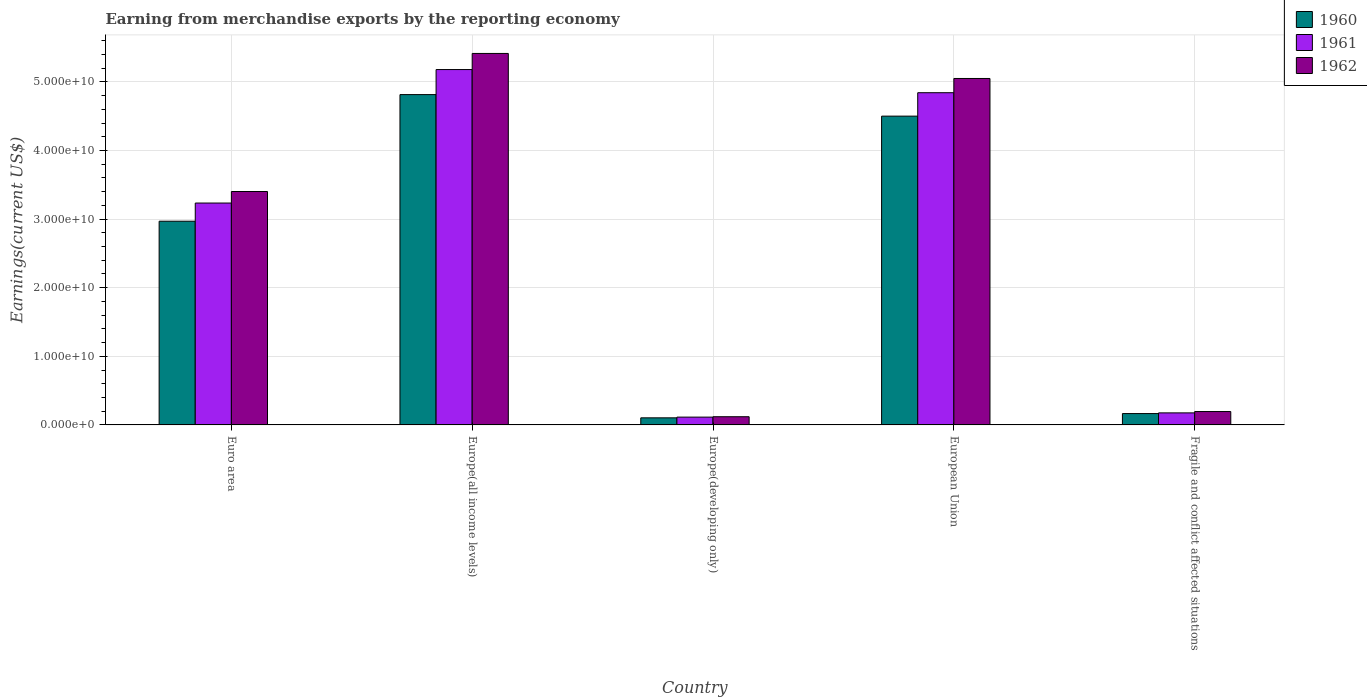Are the number of bars per tick equal to the number of legend labels?
Provide a short and direct response. Yes. How many bars are there on the 4th tick from the right?
Provide a succinct answer. 3. What is the amount earned from merchandise exports in 1960 in Europe(developing only)?
Your response must be concise. 1.03e+09. Across all countries, what is the maximum amount earned from merchandise exports in 1961?
Keep it short and to the point. 5.18e+1. Across all countries, what is the minimum amount earned from merchandise exports in 1962?
Keep it short and to the point. 1.19e+09. In which country was the amount earned from merchandise exports in 1960 maximum?
Offer a very short reply. Europe(all income levels). In which country was the amount earned from merchandise exports in 1960 minimum?
Keep it short and to the point. Europe(developing only). What is the total amount earned from merchandise exports in 1961 in the graph?
Ensure brevity in your answer.  1.35e+11. What is the difference between the amount earned from merchandise exports in 1962 in European Union and that in Fragile and conflict affected situations?
Ensure brevity in your answer.  4.86e+1. What is the difference between the amount earned from merchandise exports in 1961 in Europe(developing only) and the amount earned from merchandise exports in 1962 in Euro area?
Keep it short and to the point. -3.29e+1. What is the average amount earned from merchandise exports in 1962 per country?
Keep it short and to the point. 2.84e+1. What is the difference between the amount earned from merchandise exports of/in 1962 and amount earned from merchandise exports of/in 1961 in Fragile and conflict affected situations?
Offer a very short reply. 1.95e+08. In how many countries, is the amount earned from merchandise exports in 1960 greater than 20000000000 US$?
Provide a short and direct response. 3. What is the ratio of the amount earned from merchandise exports in 1962 in Euro area to that in Europe(all income levels)?
Your answer should be compact. 0.63. What is the difference between the highest and the second highest amount earned from merchandise exports in 1962?
Your response must be concise. 3.65e+09. What is the difference between the highest and the lowest amount earned from merchandise exports in 1961?
Keep it short and to the point. 5.07e+1. In how many countries, is the amount earned from merchandise exports in 1962 greater than the average amount earned from merchandise exports in 1962 taken over all countries?
Keep it short and to the point. 3. Is the sum of the amount earned from merchandise exports in 1961 in Europe(all income levels) and Fragile and conflict affected situations greater than the maximum amount earned from merchandise exports in 1960 across all countries?
Make the answer very short. Yes. Are all the bars in the graph horizontal?
Make the answer very short. No. Does the graph contain any zero values?
Your answer should be compact. No. Does the graph contain grids?
Your answer should be very brief. Yes. Where does the legend appear in the graph?
Provide a succinct answer. Top right. How many legend labels are there?
Provide a succinct answer. 3. How are the legend labels stacked?
Provide a short and direct response. Vertical. What is the title of the graph?
Your response must be concise. Earning from merchandise exports by the reporting economy. Does "2015" appear as one of the legend labels in the graph?
Give a very brief answer. No. What is the label or title of the Y-axis?
Make the answer very short. Earnings(current US$). What is the Earnings(current US$) in 1960 in Euro area?
Keep it short and to the point. 2.97e+1. What is the Earnings(current US$) in 1961 in Euro area?
Offer a terse response. 3.23e+1. What is the Earnings(current US$) in 1962 in Euro area?
Your response must be concise. 3.40e+1. What is the Earnings(current US$) in 1960 in Europe(all income levels)?
Offer a very short reply. 4.82e+1. What is the Earnings(current US$) of 1961 in Europe(all income levels)?
Give a very brief answer. 5.18e+1. What is the Earnings(current US$) of 1962 in Europe(all income levels)?
Make the answer very short. 5.42e+1. What is the Earnings(current US$) in 1960 in Europe(developing only)?
Make the answer very short. 1.03e+09. What is the Earnings(current US$) in 1961 in Europe(developing only)?
Make the answer very short. 1.14e+09. What is the Earnings(current US$) of 1962 in Europe(developing only)?
Ensure brevity in your answer.  1.19e+09. What is the Earnings(current US$) of 1960 in European Union?
Provide a succinct answer. 4.50e+1. What is the Earnings(current US$) in 1961 in European Union?
Give a very brief answer. 4.84e+1. What is the Earnings(current US$) in 1962 in European Union?
Your response must be concise. 5.05e+1. What is the Earnings(current US$) in 1960 in Fragile and conflict affected situations?
Offer a very short reply. 1.65e+09. What is the Earnings(current US$) of 1961 in Fragile and conflict affected situations?
Offer a very short reply. 1.75e+09. What is the Earnings(current US$) of 1962 in Fragile and conflict affected situations?
Ensure brevity in your answer.  1.95e+09. Across all countries, what is the maximum Earnings(current US$) in 1960?
Give a very brief answer. 4.82e+1. Across all countries, what is the maximum Earnings(current US$) in 1961?
Make the answer very short. 5.18e+1. Across all countries, what is the maximum Earnings(current US$) of 1962?
Your answer should be compact. 5.42e+1. Across all countries, what is the minimum Earnings(current US$) of 1960?
Provide a succinct answer. 1.03e+09. Across all countries, what is the minimum Earnings(current US$) of 1961?
Your answer should be compact. 1.14e+09. Across all countries, what is the minimum Earnings(current US$) in 1962?
Provide a short and direct response. 1.19e+09. What is the total Earnings(current US$) of 1960 in the graph?
Your response must be concise. 1.26e+11. What is the total Earnings(current US$) in 1961 in the graph?
Your response must be concise. 1.35e+11. What is the total Earnings(current US$) of 1962 in the graph?
Give a very brief answer. 1.42e+11. What is the difference between the Earnings(current US$) in 1960 in Euro area and that in Europe(all income levels)?
Ensure brevity in your answer.  -1.85e+1. What is the difference between the Earnings(current US$) of 1961 in Euro area and that in Europe(all income levels)?
Provide a short and direct response. -1.95e+1. What is the difference between the Earnings(current US$) of 1962 in Euro area and that in Europe(all income levels)?
Keep it short and to the point. -2.01e+1. What is the difference between the Earnings(current US$) in 1960 in Euro area and that in Europe(developing only)?
Give a very brief answer. 2.87e+1. What is the difference between the Earnings(current US$) in 1961 in Euro area and that in Europe(developing only)?
Keep it short and to the point. 3.12e+1. What is the difference between the Earnings(current US$) in 1962 in Euro area and that in Europe(developing only)?
Offer a very short reply. 3.28e+1. What is the difference between the Earnings(current US$) of 1960 in Euro area and that in European Union?
Offer a very short reply. -1.53e+1. What is the difference between the Earnings(current US$) of 1961 in Euro area and that in European Union?
Keep it short and to the point. -1.61e+1. What is the difference between the Earnings(current US$) of 1962 in Euro area and that in European Union?
Give a very brief answer. -1.65e+1. What is the difference between the Earnings(current US$) of 1960 in Euro area and that in Fragile and conflict affected situations?
Ensure brevity in your answer.  2.80e+1. What is the difference between the Earnings(current US$) of 1961 in Euro area and that in Fragile and conflict affected situations?
Provide a short and direct response. 3.06e+1. What is the difference between the Earnings(current US$) in 1962 in Euro area and that in Fragile and conflict affected situations?
Make the answer very short. 3.21e+1. What is the difference between the Earnings(current US$) of 1960 in Europe(all income levels) and that in Europe(developing only)?
Make the answer very short. 4.71e+1. What is the difference between the Earnings(current US$) of 1961 in Europe(all income levels) and that in Europe(developing only)?
Offer a terse response. 5.07e+1. What is the difference between the Earnings(current US$) of 1962 in Europe(all income levels) and that in Europe(developing only)?
Offer a very short reply. 5.30e+1. What is the difference between the Earnings(current US$) of 1960 in Europe(all income levels) and that in European Union?
Give a very brief answer. 3.14e+09. What is the difference between the Earnings(current US$) of 1961 in Europe(all income levels) and that in European Union?
Provide a short and direct response. 3.38e+09. What is the difference between the Earnings(current US$) of 1962 in Europe(all income levels) and that in European Union?
Keep it short and to the point. 3.65e+09. What is the difference between the Earnings(current US$) of 1960 in Europe(all income levels) and that in Fragile and conflict affected situations?
Your answer should be very brief. 4.65e+1. What is the difference between the Earnings(current US$) in 1961 in Europe(all income levels) and that in Fragile and conflict affected situations?
Provide a short and direct response. 5.00e+1. What is the difference between the Earnings(current US$) in 1962 in Europe(all income levels) and that in Fragile and conflict affected situations?
Your answer should be compact. 5.22e+1. What is the difference between the Earnings(current US$) in 1960 in Europe(developing only) and that in European Union?
Offer a very short reply. -4.40e+1. What is the difference between the Earnings(current US$) of 1961 in Europe(developing only) and that in European Union?
Offer a very short reply. -4.73e+1. What is the difference between the Earnings(current US$) in 1962 in Europe(developing only) and that in European Union?
Offer a very short reply. -4.93e+1. What is the difference between the Earnings(current US$) in 1960 in Europe(developing only) and that in Fragile and conflict affected situations?
Offer a terse response. -6.22e+08. What is the difference between the Earnings(current US$) of 1961 in Europe(developing only) and that in Fragile and conflict affected situations?
Provide a succinct answer. -6.19e+08. What is the difference between the Earnings(current US$) in 1962 in Europe(developing only) and that in Fragile and conflict affected situations?
Give a very brief answer. -7.55e+08. What is the difference between the Earnings(current US$) in 1960 in European Union and that in Fragile and conflict affected situations?
Make the answer very short. 4.34e+1. What is the difference between the Earnings(current US$) in 1961 in European Union and that in Fragile and conflict affected situations?
Offer a very short reply. 4.67e+1. What is the difference between the Earnings(current US$) in 1962 in European Union and that in Fragile and conflict affected situations?
Ensure brevity in your answer.  4.86e+1. What is the difference between the Earnings(current US$) of 1960 in Euro area and the Earnings(current US$) of 1961 in Europe(all income levels)?
Provide a succinct answer. -2.21e+1. What is the difference between the Earnings(current US$) of 1960 in Euro area and the Earnings(current US$) of 1962 in Europe(all income levels)?
Give a very brief answer. -2.45e+1. What is the difference between the Earnings(current US$) of 1961 in Euro area and the Earnings(current US$) of 1962 in Europe(all income levels)?
Offer a very short reply. -2.18e+1. What is the difference between the Earnings(current US$) in 1960 in Euro area and the Earnings(current US$) in 1961 in Europe(developing only)?
Your answer should be compact. 2.86e+1. What is the difference between the Earnings(current US$) of 1960 in Euro area and the Earnings(current US$) of 1962 in Europe(developing only)?
Ensure brevity in your answer.  2.85e+1. What is the difference between the Earnings(current US$) in 1961 in Euro area and the Earnings(current US$) in 1962 in Europe(developing only)?
Make the answer very short. 3.12e+1. What is the difference between the Earnings(current US$) in 1960 in Euro area and the Earnings(current US$) in 1961 in European Union?
Keep it short and to the point. -1.87e+1. What is the difference between the Earnings(current US$) in 1960 in Euro area and the Earnings(current US$) in 1962 in European Union?
Provide a short and direct response. -2.08e+1. What is the difference between the Earnings(current US$) of 1961 in Euro area and the Earnings(current US$) of 1962 in European Union?
Provide a succinct answer. -1.82e+1. What is the difference between the Earnings(current US$) of 1960 in Euro area and the Earnings(current US$) of 1961 in Fragile and conflict affected situations?
Offer a terse response. 2.79e+1. What is the difference between the Earnings(current US$) in 1960 in Euro area and the Earnings(current US$) in 1962 in Fragile and conflict affected situations?
Offer a very short reply. 2.77e+1. What is the difference between the Earnings(current US$) of 1961 in Euro area and the Earnings(current US$) of 1962 in Fragile and conflict affected situations?
Make the answer very short. 3.04e+1. What is the difference between the Earnings(current US$) in 1960 in Europe(all income levels) and the Earnings(current US$) in 1961 in Europe(developing only)?
Provide a succinct answer. 4.70e+1. What is the difference between the Earnings(current US$) in 1960 in Europe(all income levels) and the Earnings(current US$) in 1962 in Europe(developing only)?
Your answer should be very brief. 4.70e+1. What is the difference between the Earnings(current US$) in 1961 in Europe(all income levels) and the Earnings(current US$) in 1962 in Europe(developing only)?
Your answer should be very brief. 5.06e+1. What is the difference between the Earnings(current US$) in 1960 in Europe(all income levels) and the Earnings(current US$) in 1961 in European Union?
Your response must be concise. -2.75e+08. What is the difference between the Earnings(current US$) of 1960 in Europe(all income levels) and the Earnings(current US$) of 1962 in European Union?
Your response must be concise. -2.35e+09. What is the difference between the Earnings(current US$) of 1961 in Europe(all income levels) and the Earnings(current US$) of 1962 in European Union?
Ensure brevity in your answer.  1.30e+09. What is the difference between the Earnings(current US$) of 1960 in Europe(all income levels) and the Earnings(current US$) of 1961 in Fragile and conflict affected situations?
Keep it short and to the point. 4.64e+1. What is the difference between the Earnings(current US$) of 1960 in Europe(all income levels) and the Earnings(current US$) of 1962 in Fragile and conflict affected situations?
Give a very brief answer. 4.62e+1. What is the difference between the Earnings(current US$) in 1961 in Europe(all income levels) and the Earnings(current US$) in 1962 in Fragile and conflict affected situations?
Keep it short and to the point. 4.99e+1. What is the difference between the Earnings(current US$) of 1960 in Europe(developing only) and the Earnings(current US$) of 1961 in European Union?
Give a very brief answer. -4.74e+1. What is the difference between the Earnings(current US$) in 1960 in Europe(developing only) and the Earnings(current US$) in 1962 in European Union?
Offer a terse response. -4.95e+1. What is the difference between the Earnings(current US$) in 1961 in Europe(developing only) and the Earnings(current US$) in 1962 in European Union?
Keep it short and to the point. -4.94e+1. What is the difference between the Earnings(current US$) in 1960 in Europe(developing only) and the Earnings(current US$) in 1961 in Fragile and conflict affected situations?
Offer a terse response. -7.23e+08. What is the difference between the Earnings(current US$) in 1960 in Europe(developing only) and the Earnings(current US$) in 1962 in Fragile and conflict affected situations?
Make the answer very short. -9.17e+08. What is the difference between the Earnings(current US$) in 1961 in Europe(developing only) and the Earnings(current US$) in 1962 in Fragile and conflict affected situations?
Offer a very short reply. -8.14e+08. What is the difference between the Earnings(current US$) of 1960 in European Union and the Earnings(current US$) of 1961 in Fragile and conflict affected situations?
Ensure brevity in your answer.  4.33e+1. What is the difference between the Earnings(current US$) in 1960 in European Union and the Earnings(current US$) in 1962 in Fragile and conflict affected situations?
Your response must be concise. 4.31e+1. What is the difference between the Earnings(current US$) in 1961 in European Union and the Earnings(current US$) in 1962 in Fragile and conflict affected situations?
Your answer should be very brief. 4.65e+1. What is the average Earnings(current US$) in 1960 per country?
Provide a short and direct response. 2.51e+1. What is the average Earnings(current US$) of 1961 per country?
Your answer should be very brief. 2.71e+1. What is the average Earnings(current US$) in 1962 per country?
Provide a short and direct response. 2.84e+1. What is the difference between the Earnings(current US$) of 1960 and Earnings(current US$) of 1961 in Euro area?
Your response must be concise. -2.65e+09. What is the difference between the Earnings(current US$) of 1960 and Earnings(current US$) of 1962 in Euro area?
Provide a succinct answer. -4.33e+09. What is the difference between the Earnings(current US$) of 1961 and Earnings(current US$) of 1962 in Euro area?
Offer a terse response. -1.68e+09. What is the difference between the Earnings(current US$) of 1960 and Earnings(current US$) of 1961 in Europe(all income levels)?
Keep it short and to the point. -3.65e+09. What is the difference between the Earnings(current US$) of 1960 and Earnings(current US$) of 1962 in Europe(all income levels)?
Provide a short and direct response. -6.00e+09. What is the difference between the Earnings(current US$) in 1961 and Earnings(current US$) in 1962 in Europe(all income levels)?
Make the answer very short. -2.35e+09. What is the difference between the Earnings(current US$) in 1960 and Earnings(current US$) in 1961 in Europe(developing only)?
Provide a succinct answer. -1.04e+08. What is the difference between the Earnings(current US$) of 1960 and Earnings(current US$) of 1962 in Europe(developing only)?
Offer a terse response. -1.62e+08. What is the difference between the Earnings(current US$) of 1961 and Earnings(current US$) of 1962 in Europe(developing only)?
Offer a very short reply. -5.88e+07. What is the difference between the Earnings(current US$) of 1960 and Earnings(current US$) of 1961 in European Union?
Ensure brevity in your answer.  -3.41e+09. What is the difference between the Earnings(current US$) of 1960 and Earnings(current US$) of 1962 in European Union?
Your response must be concise. -5.49e+09. What is the difference between the Earnings(current US$) of 1961 and Earnings(current US$) of 1962 in European Union?
Your response must be concise. -2.08e+09. What is the difference between the Earnings(current US$) in 1960 and Earnings(current US$) in 1961 in Fragile and conflict affected situations?
Keep it short and to the point. -1.01e+08. What is the difference between the Earnings(current US$) in 1960 and Earnings(current US$) in 1962 in Fragile and conflict affected situations?
Offer a very short reply. -2.96e+08. What is the difference between the Earnings(current US$) in 1961 and Earnings(current US$) in 1962 in Fragile and conflict affected situations?
Offer a terse response. -1.95e+08. What is the ratio of the Earnings(current US$) in 1960 in Euro area to that in Europe(all income levels)?
Ensure brevity in your answer.  0.62. What is the ratio of the Earnings(current US$) of 1961 in Euro area to that in Europe(all income levels)?
Ensure brevity in your answer.  0.62. What is the ratio of the Earnings(current US$) in 1962 in Euro area to that in Europe(all income levels)?
Provide a short and direct response. 0.63. What is the ratio of the Earnings(current US$) of 1960 in Euro area to that in Europe(developing only)?
Make the answer very short. 28.78. What is the ratio of the Earnings(current US$) of 1961 in Euro area to that in Europe(developing only)?
Give a very brief answer. 28.49. What is the ratio of the Earnings(current US$) in 1962 in Euro area to that in Europe(developing only)?
Offer a terse response. 28.49. What is the ratio of the Earnings(current US$) of 1960 in Euro area to that in European Union?
Ensure brevity in your answer.  0.66. What is the ratio of the Earnings(current US$) of 1961 in Euro area to that in European Union?
Keep it short and to the point. 0.67. What is the ratio of the Earnings(current US$) in 1962 in Euro area to that in European Union?
Keep it short and to the point. 0.67. What is the ratio of the Earnings(current US$) of 1960 in Euro area to that in Fragile and conflict affected situations?
Your response must be concise. 17.96. What is the ratio of the Earnings(current US$) of 1961 in Euro area to that in Fragile and conflict affected situations?
Your answer should be compact. 18.44. What is the ratio of the Earnings(current US$) of 1962 in Euro area to that in Fragile and conflict affected situations?
Give a very brief answer. 17.46. What is the ratio of the Earnings(current US$) in 1960 in Europe(all income levels) to that in Europe(developing only)?
Provide a short and direct response. 46.67. What is the ratio of the Earnings(current US$) of 1961 in Europe(all income levels) to that in Europe(developing only)?
Provide a succinct answer. 45.63. What is the ratio of the Earnings(current US$) in 1962 in Europe(all income levels) to that in Europe(developing only)?
Your answer should be very brief. 45.35. What is the ratio of the Earnings(current US$) in 1960 in Europe(all income levels) to that in European Union?
Ensure brevity in your answer.  1.07. What is the ratio of the Earnings(current US$) in 1961 in Europe(all income levels) to that in European Union?
Offer a very short reply. 1.07. What is the ratio of the Earnings(current US$) of 1962 in Europe(all income levels) to that in European Union?
Your response must be concise. 1.07. What is the ratio of the Earnings(current US$) of 1960 in Europe(all income levels) to that in Fragile and conflict affected situations?
Ensure brevity in your answer.  29.12. What is the ratio of the Earnings(current US$) of 1961 in Europe(all income levels) to that in Fragile and conflict affected situations?
Provide a short and direct response. 29.53. What is the ratio of the Earnings(current US$) of 1962 in Europe(all income levels) to that in Fragile and conflict affected situations?
Your answer should be very brief. 27.78. What is the ratio of the Earnings(current US$) in 1960 in Europe(developing only) to that in European Union?
Ensure brevity in your answer.  0.02. What is the ratio of the Earnings(current US$) of 1961 in Europe(developing only) to that in European Union?
Provide a short and direct response. 0.02. What is the ratio of the Earnings(current US$) in 1962 in Europe(developing only) to that in European Union?
Offer a very short reply. 0.02. What is the ratio of the Earnings(current US$) in 1960 in Europe(developing only) to that in Fragile and conflict affected situations?
Your response must be concise. 0.62. What is the ratio of the Earnings(current US$) of 1961 in Europe(developing only) to that in Fragile and conflict affected situations?
Ensure brevity in your answer.  0.65. What is the ratio of the Earnings(current US$) in 1962 in Europe(developing only) to that in Fragile and conflict affected situations?
Make the answer very short. 0.61. What is the ratio of the Earnings(current US$) of 1960 in European Union to that in Fragile and conflict affected situations?
Your response must be concise. 27.22. What is the ratio of the Earnings(current US$) in 1961 in European Union to that in Fragile and conflict affected situations?
Provide a succinct answer. 27.6. What is the ratio of the Earnings(current US$) in 1962 in European Union to that in Fragile and conflict affected situations?
Ensure brevity in your answer.  25.91. What is the difference between the highest and the second highest Earnings(current US$) of 1960?
Offer a very short reply. 3.14e+09. What is the difference between the highest and the second highest Earnings(current US$) in 1961?
Your response must be concise. 3.38e+09. What is the difference between the highest and the second highest Earnings(current US$) in 1962?
Offer a very short reply. 3.65e+09. What is the difference between the highest and the lowest Earnings(current US$) of 1960?
Provide a short and direct response. 4.71e+1. What is the difference between the highest and the lowest Earnings(current US$) in 1961?
Your answer should be compact. 5.07e+1. What is the difference between the highest and the lowest Earnings(current US$) of 1962?
Ensure brevity in your answer.  5.30e+1. 